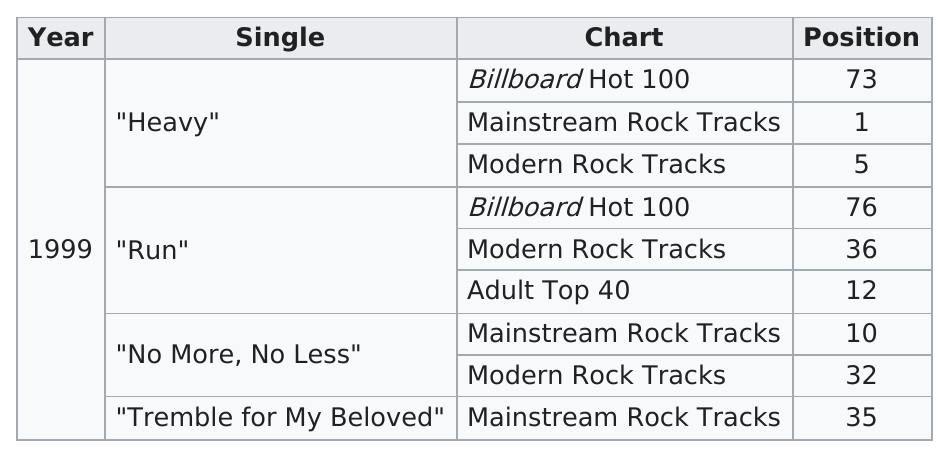Identify some key points in this picture. Four singles from the album have made it onto the charts. The songs 'Heavy' and 'Run' from the album "dosage" appeared on the Billboard Hot 100 chart. Run" made a total of three different charts. The modern rock tracks chart's single that performed the best is "Heavy. The song with the highest Billboard Hot 100 rating from Shaed's album "dosage" is "Heavy". 